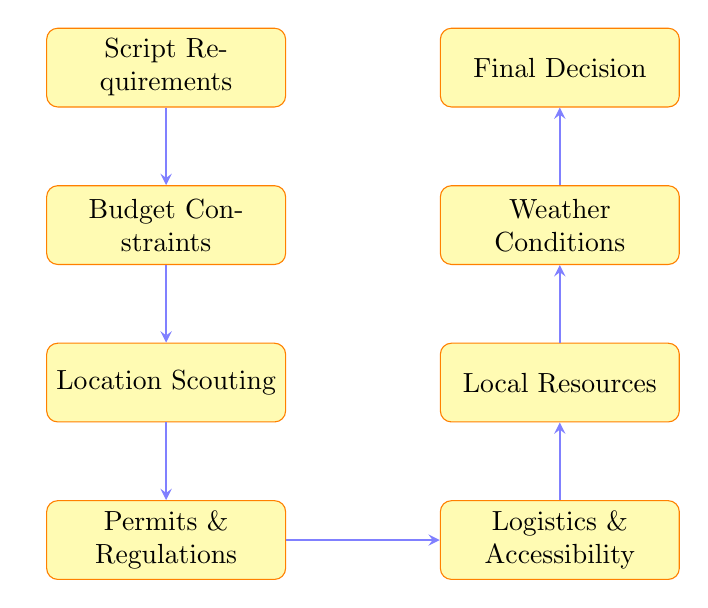What is the first node in the flow chart? The first node is "Script Requirements," which is the starting point of the decision-making process for choosing a filming location.
Answer: Script Requirements How many nodes are there in the diagram? The diagram contains a total of eight nodes. Each one represents a step in the decision-making process.
Answer: 8 What is the relationship between "Location Scouting" and "Permits & Regulations"? "Location Scouting" leads directly to "Permits & Regulations," indicating that after scouting locations, checking legal requirements is the next step.
Answer: Lead to Which node comes after "Weather Conditions"? After "Weather Conditions," the next node is "Final Decision," which is where the filming location is ultimately chosen based on all previous analyses.
Answer: Final Decision What aspect is assessed in the "Logistics & Accessibility" node? The "Logistics & Accessibility" node assesses the ease of transporting crew and equipment as well as the location's accessibility.
Answer: Transportation and accessibility What is the last stage in the decision-making process depicted in the diagram? The last stage is "Final Decision," which reflects the culmination of all prior considerations.
Answer: Final Decision What type of resources are evaluated in the "Local Resources" node? The "Local Resources" node evaluates the availability of local talent, crew, and equipment rental necessary for production.
Answer: Talent, crew, and equipment rental What is a prerequisite for "Location Scouting"? "Budget Constraints" must be evaluated before proceeding to "Location Scouting," as the budget determines feasible locations.
Answer: Budget Constraints 